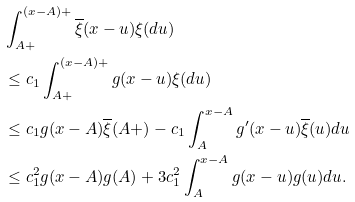<formula> <loc_0><loc_0><loc_500><loc_500>& \int _ { A + } ^ { ( x - A ) + } \overline { \xi } ( x - u ) \xi ( d u ) \\ & \leq c _ { 1 } \int _ { A + } ^ { ( x - A ) + } g ( x - u ) \xi ( d u ) \\ & \leq c _ { 1 } g ( x - A ) \overline { \xi } ( A + ) - c _ { 1 } \int _ { A } ^ { x - A } g ^ { \prime } ( x - u ) \overline { \xi } ( u ) d u \\ & \leq c _ { 1 } ^ { 2 } g ( x - A ) g ( A ) + 3 c _ { 1 } ^ { 2 } \int _ { A } ^ { x - A } g ( x - u ) g ( u ) d u .</formula> 